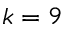Convert formula to latex. <formula><loc_0><loc_0><loc_500><loc_500>k = 9</formula> 